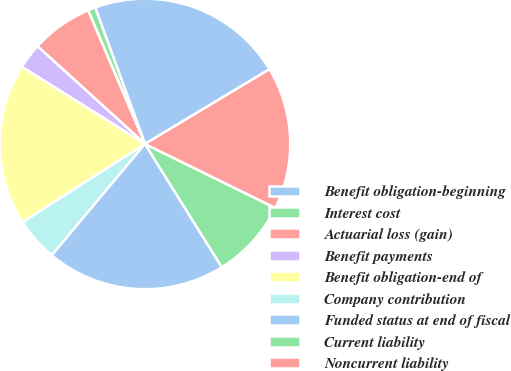Convert chart. <chart><loc_0><loc_0><loc_500><loc_500><pie_chart><fcel>Benefit obligation-beginning<fcel>Interest cost<fcel>Actuarial loss (gain)<fcel>Benefit payments<fcel>Benefit obligation-end of<fcel>Company contribution<fcel>Funded status at end of fiscal<fcel>Current liability<fcel>Noncurrent liability<nl><fcel>21.97%<fcel>0.84%<fcel>6.85%<fcel>2.84%<fcel>17.96%<fcel>4.85%<fcel>19.97%<fcel>8.86%<fcel>15.87%<nl></chart> 